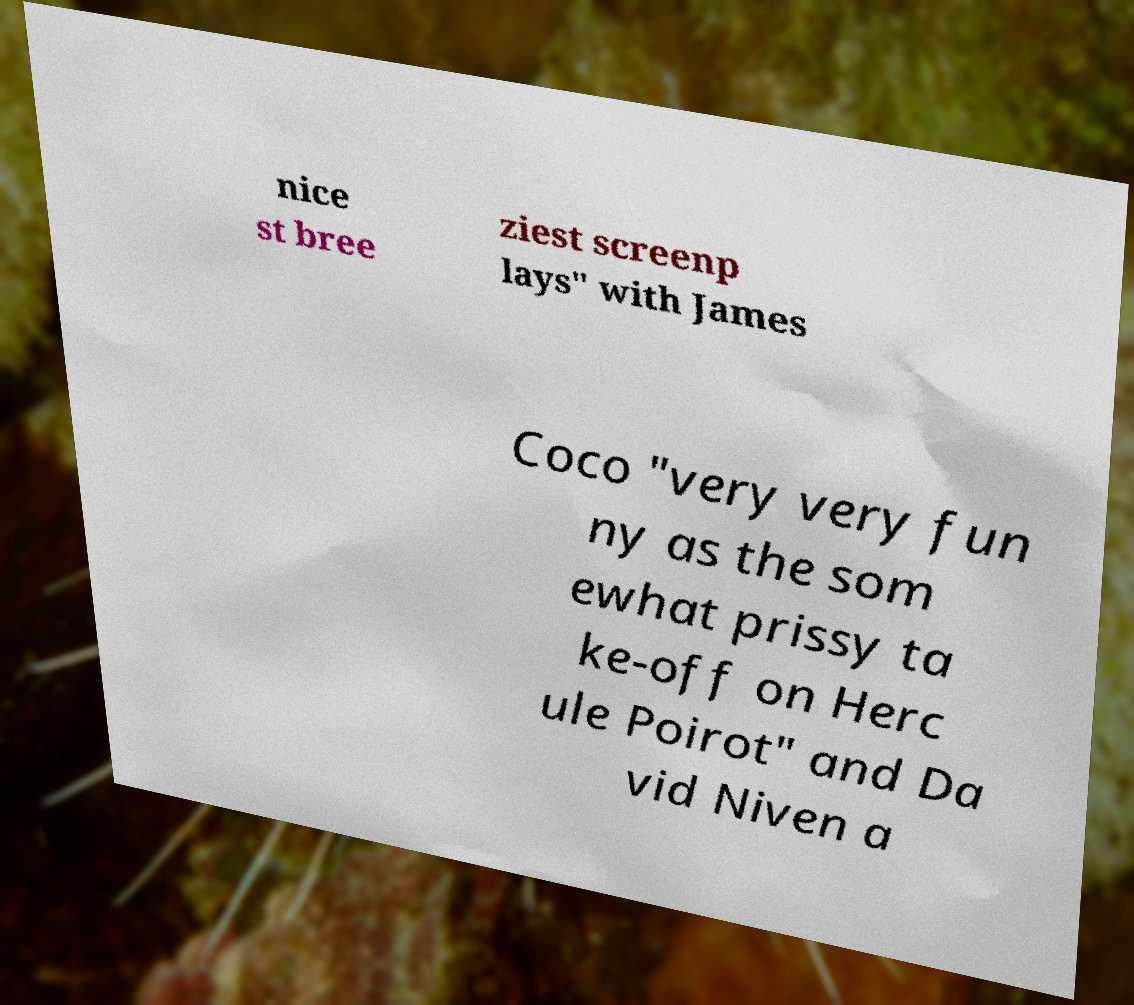There's text embedded in this image that I need extracted. Can you transcribe it verbatim? nice st bree ziest screenp lays" with James Coco "very very fun ny as the som ewhat prissy ta ke-off on Herc ule Poirot" and Da vid Niven a 